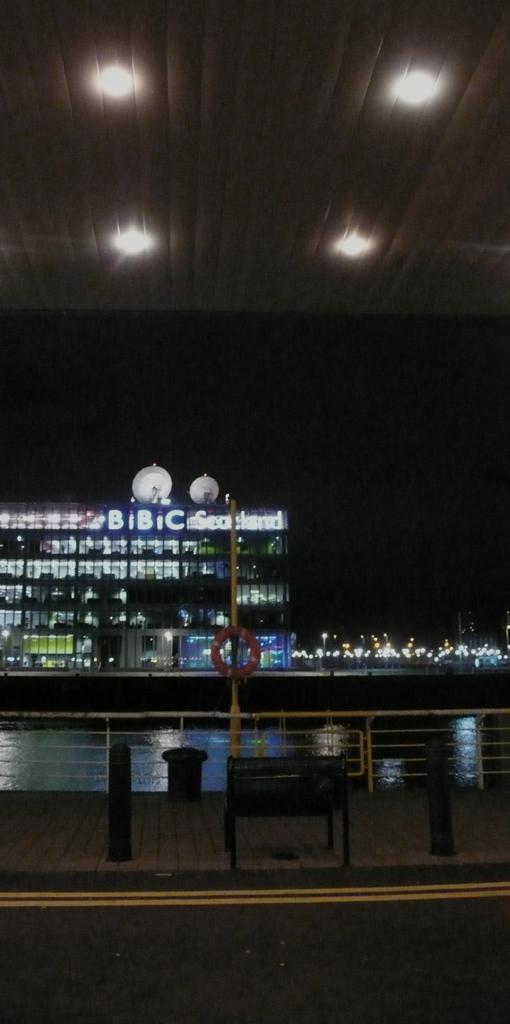Can you describe this image briefly? In this image I can see the bench. In-front of the bench there is a railing and the orange color tube. I can also see the water to the side of the railing. In the back I can see the building with the lights and the sky. I can also see the road in the front. 